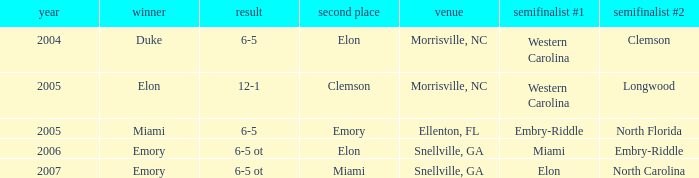When Embry-Riddle made it to the first semi finalist slot, list all the runners up. Emory. 